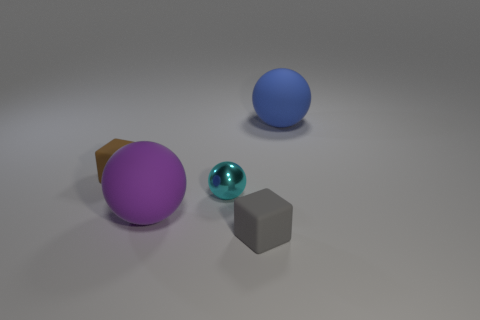Add 4 big blue things. How many objects exist? 9 Subtract all cubes. How many objects are left? 3 Add 3 big balls. How many big balls exist? 5 Subtract 1 gray blocks. How many objects are left? 4 Subtract all large blue things. Subtract all large things. How many objects are left? 2 Add 4 purple spheres. How many purple spheres are left? 5 